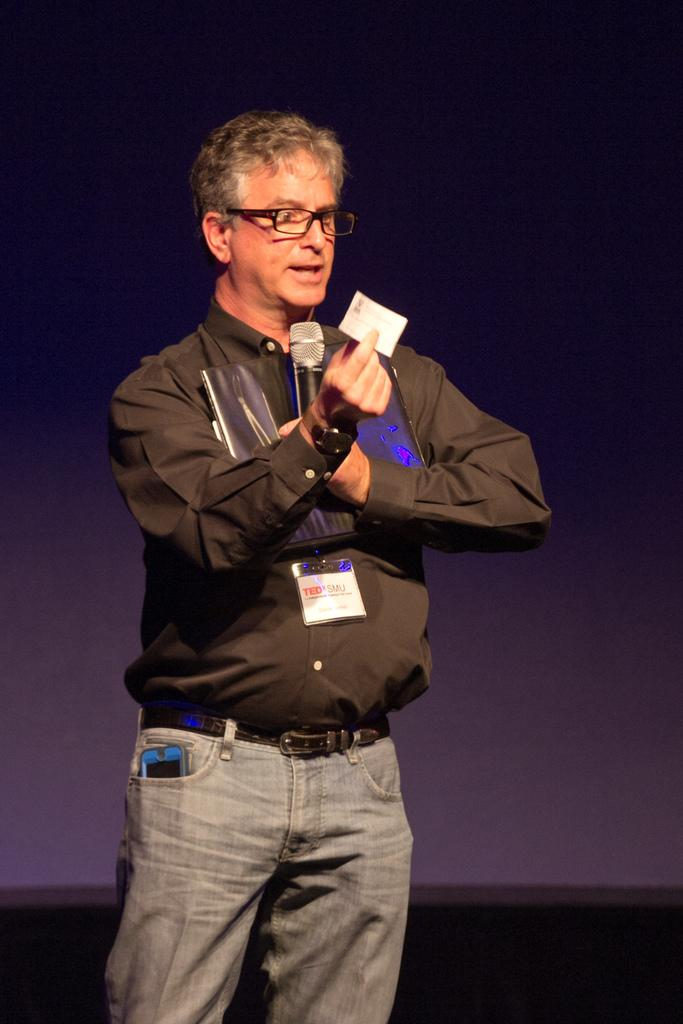What is the man on the stage doing in the image? The man is showing a card in the image. What is the man holding in his hand? The man is holding a microphone in his hand. Can you describe the man's appearance? The man is wearing spectacles. What can be seen in the background of the image? There is a wall in the background of the image. How many ladybugs are crawling on the wall in the image? There are no ladybugs present in the image; only the man and the wall are visible. 